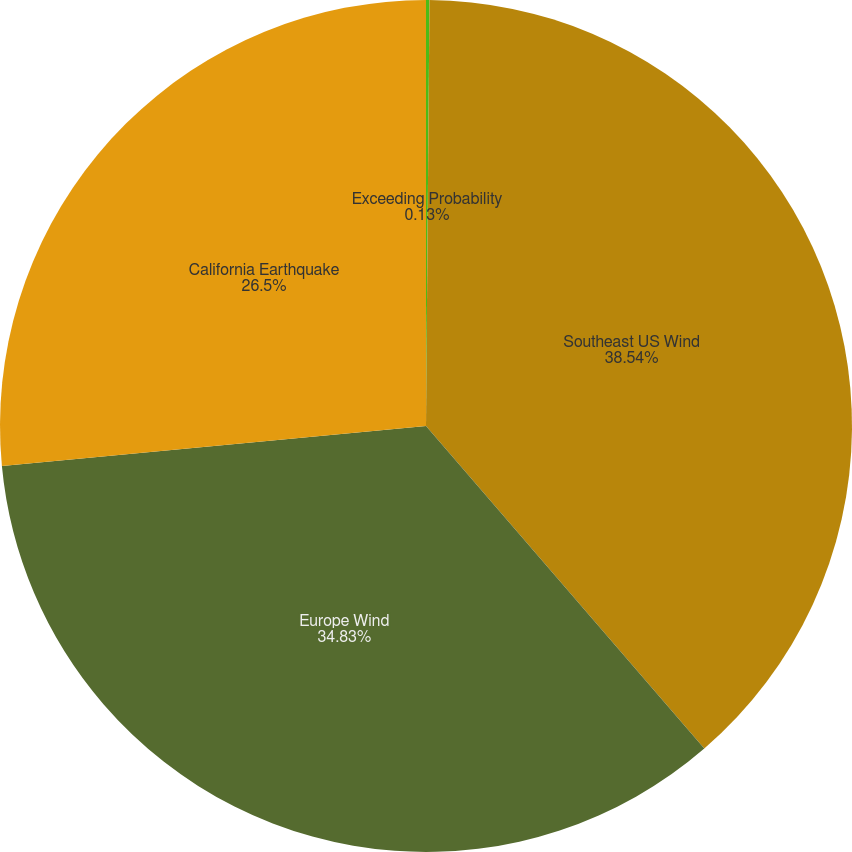<chart> <loc_0><loc_0><loc_500><loc_500><pie_chart><fcel>Exceeding Probability<fcel>Southeast US Wind<fcel>Europe Wind<fcel>California Earthquake<nl><fcel>0.13%<fcel>38.54%<fcel>34.83%<fcel>26.5%<nl></chart> 